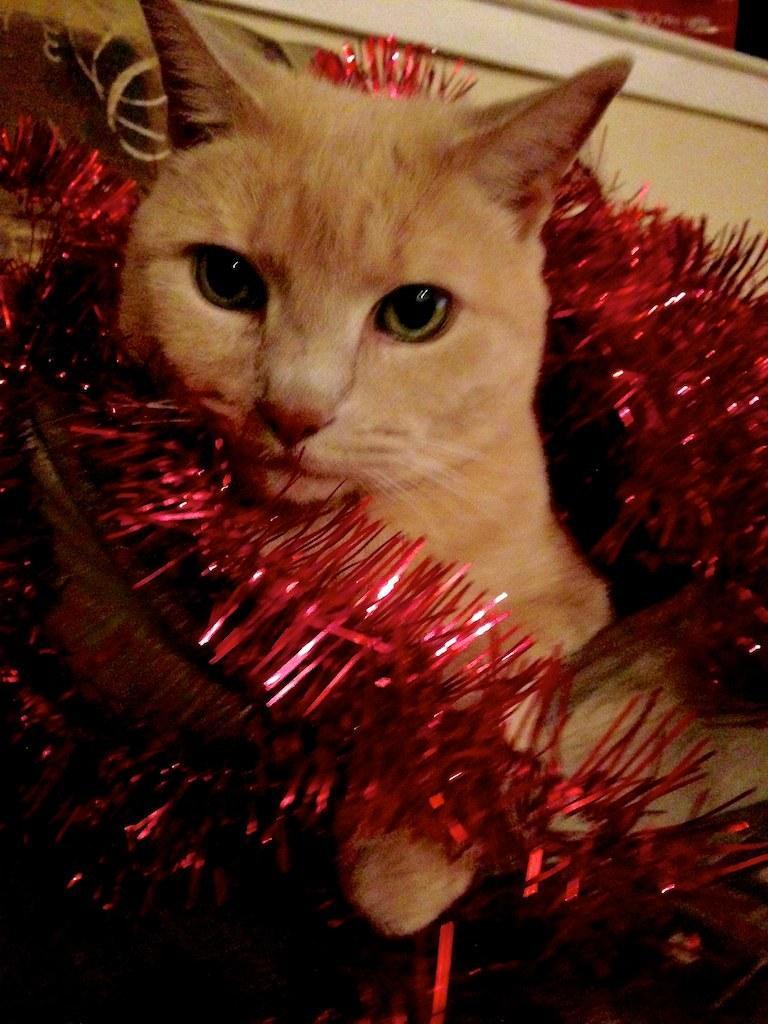Please provide a concise description of this image. In this image I can see a cat which is brown in color and a decorative thread around it which is red in color. In the background I can see the cream colored wall. 